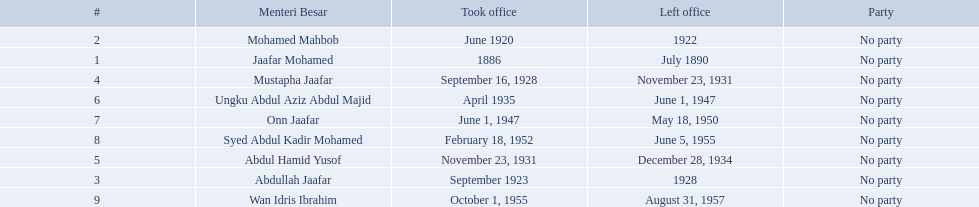Who are all of the menteri besars? Jaafar Mohamed, Mohamed Mahbob, Abdullah Jaafar, Mustapha Jaafar, Abdul Hamid Yusof, Ungku Abdul Aziz Abdul Majid, Onn Jaafar, Syed Abdul Kadir Mohamed, Wan Idris Ibrahim. When did each take office? 1886, June 1920, September 1923, September 16, 1928, November 23, 1931, April 1935, June 1, 1947, February 18, 1952, October 1, 1955. When did they leave? July 1890, 1922, 1928, November 23, 1931, December 28, 1934, June 1, 1947, May 18, 1950, June 5, 1955, August 31, 1957. And which spent the most time in office? Ungku Abdul Aziz Abdul Majid. I'm looking to parse the entire table for insights. Could you assist me with that? {'header': ['#', 'Menteri Besar', 'Took office', 'Left office', 'Party'], 'rows': [['2', 'Mohamed Mahbob', 'June 1920', '1922', 'No party'], ['1', 'Jaafar Mohamed', '1886', 'July 1890', 'No party'], ['4', 'Mustapha Jaafar', 'September 16, 1928', 'November 23, 1931', 'No party'], ['6', 'Ungku Abdul Aziz Abdul Majid', 'April 1935', 'June 1, 1947', 'No party'], ['7', 'Onn Jaafar', 'June 1, 1947', 'May 18, 1950', 'No party'], ['8', 'Syed Abdul Kadir Mohamed', 'February 18, 1952', 'June 5, 1955', 'No party'], ['5', 'Abdul Hamid Yusof', 'November 23, 1931', 'December 28, 1934', 'No party'], ['3', 'Abdullah Jaafar', 'September 1923', '1928', 'No party'], ['9', 'Wan Idris Ibrahim', 'October 1, 1955', 'August 31, 1957', 'No party']]} Which menteri besars took office in the 1920's? Mohamed Mahbob, Abdullah Jaafar, Mustapha Jaafar. Of those men, who was only in office for 2 years? Mohamed Mahbob. 